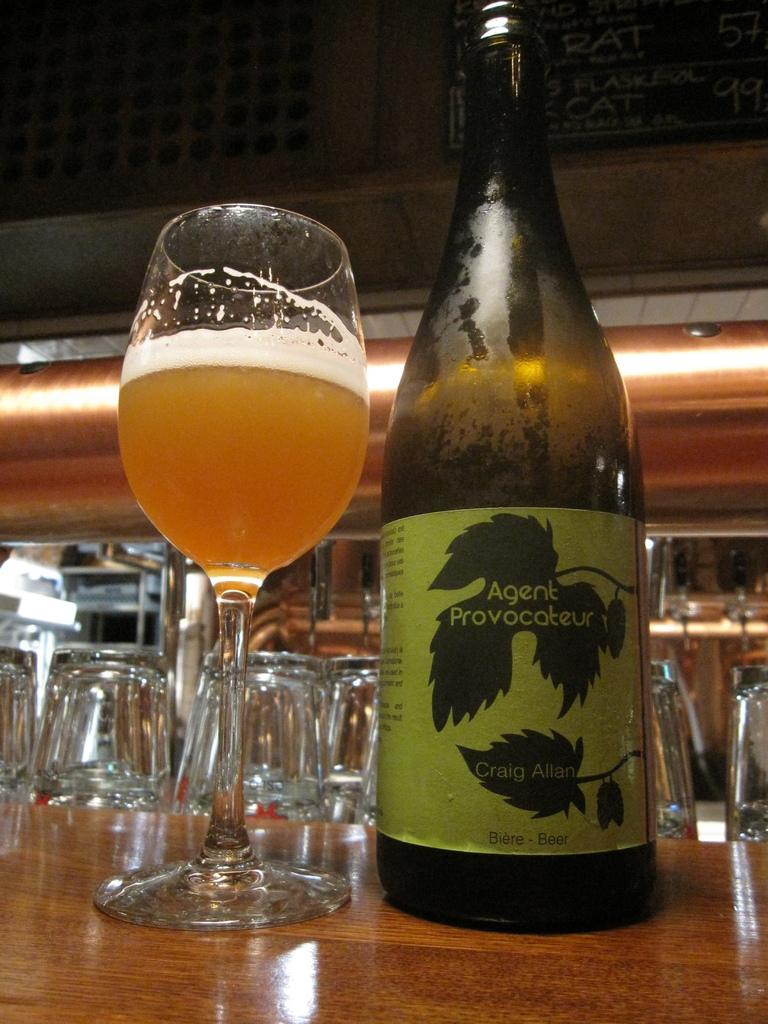Provide a one-sentence caption for the provided image. a bottle of Agent Provocateur beer is poured into the glass. 